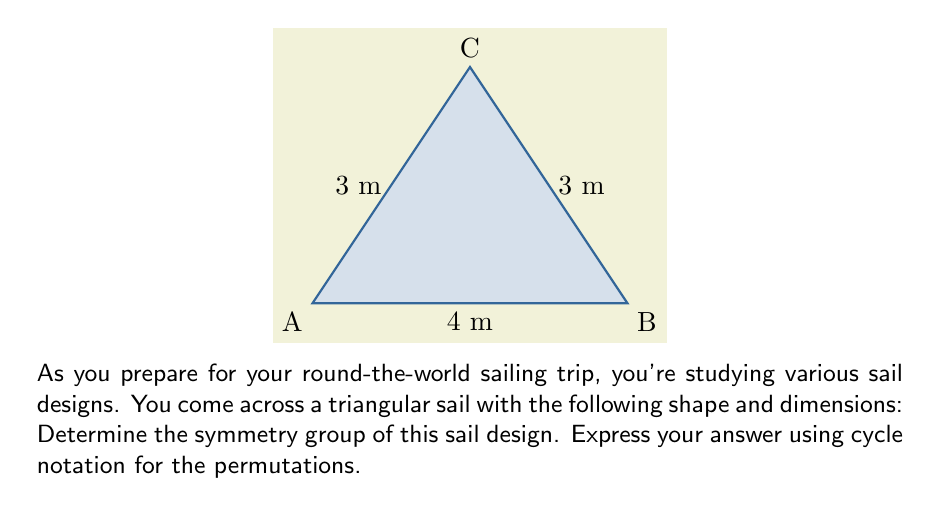Can you solve this math problem? Let's approach this step-by-step:

1) First, we need to identify all the symmetries of this triangular sail. The symmetries are the transformations that leave the shape unchanged.

2) For a triangle, we have two types of symmetries:
   - Rotations
   - Reflections

3) In this case, we have:
   - The identity transformation (do nothing)
   - One 120° rotation clockwise (or two 120° rotations counterclockwise)
   - One reflection across the altitude from C to AB

4) Let's assign numbers to the vertices:
   A = 1, B = 2, C = 3

5) Now, let's express each symmetry as a permutation in cycle notation:
   - Identity: (1)(2)(3)
   - 120° rotation clockwise: (123)
   - 240° rotation clockwise (or 120° counterclockwise): (132)
   - Reflection across the altitude: (1)(23)

6) These four permutations form a group under composition. This group is isomorphic to the dihedral group $D_3$, which is the symmetry group of an equilateral triangle.

7) The group operation table would look like this:

   $$ \begin{array}{c|cccc}
      \circ & e & r & r^2 & s \\
      \hline
      e & e & r & r^2 & s \\
      r & r & r^2 & e & sr \\
      r^2 & r^2 & e & r & sr^2 \\
      s & s & sr^2 & sr & e
   \end{array} $$

   where $e$ is the identity, $r$ is the 120° rotation, and $s$ is the reflection.
Answer: $\{(1)(2)(3), (123), (132), (1)(23)\}$ 